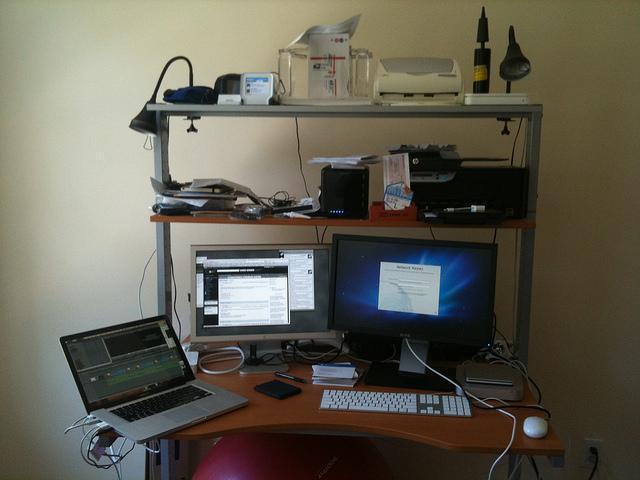How many computers?
Give a very brief answer. 3. How many keyboards are there?
Give a very brief answer. 2. How many tvs are there?
Give a very brief answer. 2. How many chairs are there?
Give a very brief answer. 1. How many sheep walking in a line in this picture?
Give a very brief answer. 0. 